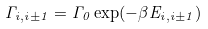Convert formula to latex. <formula><loc_0><loc_0><loc_500><loc_500>\Gamma _ { i , i \pm 1 } = \Gamma _ { 0 } \exp ( - \beta E _ { i , i \pm 1 } )</formula> 